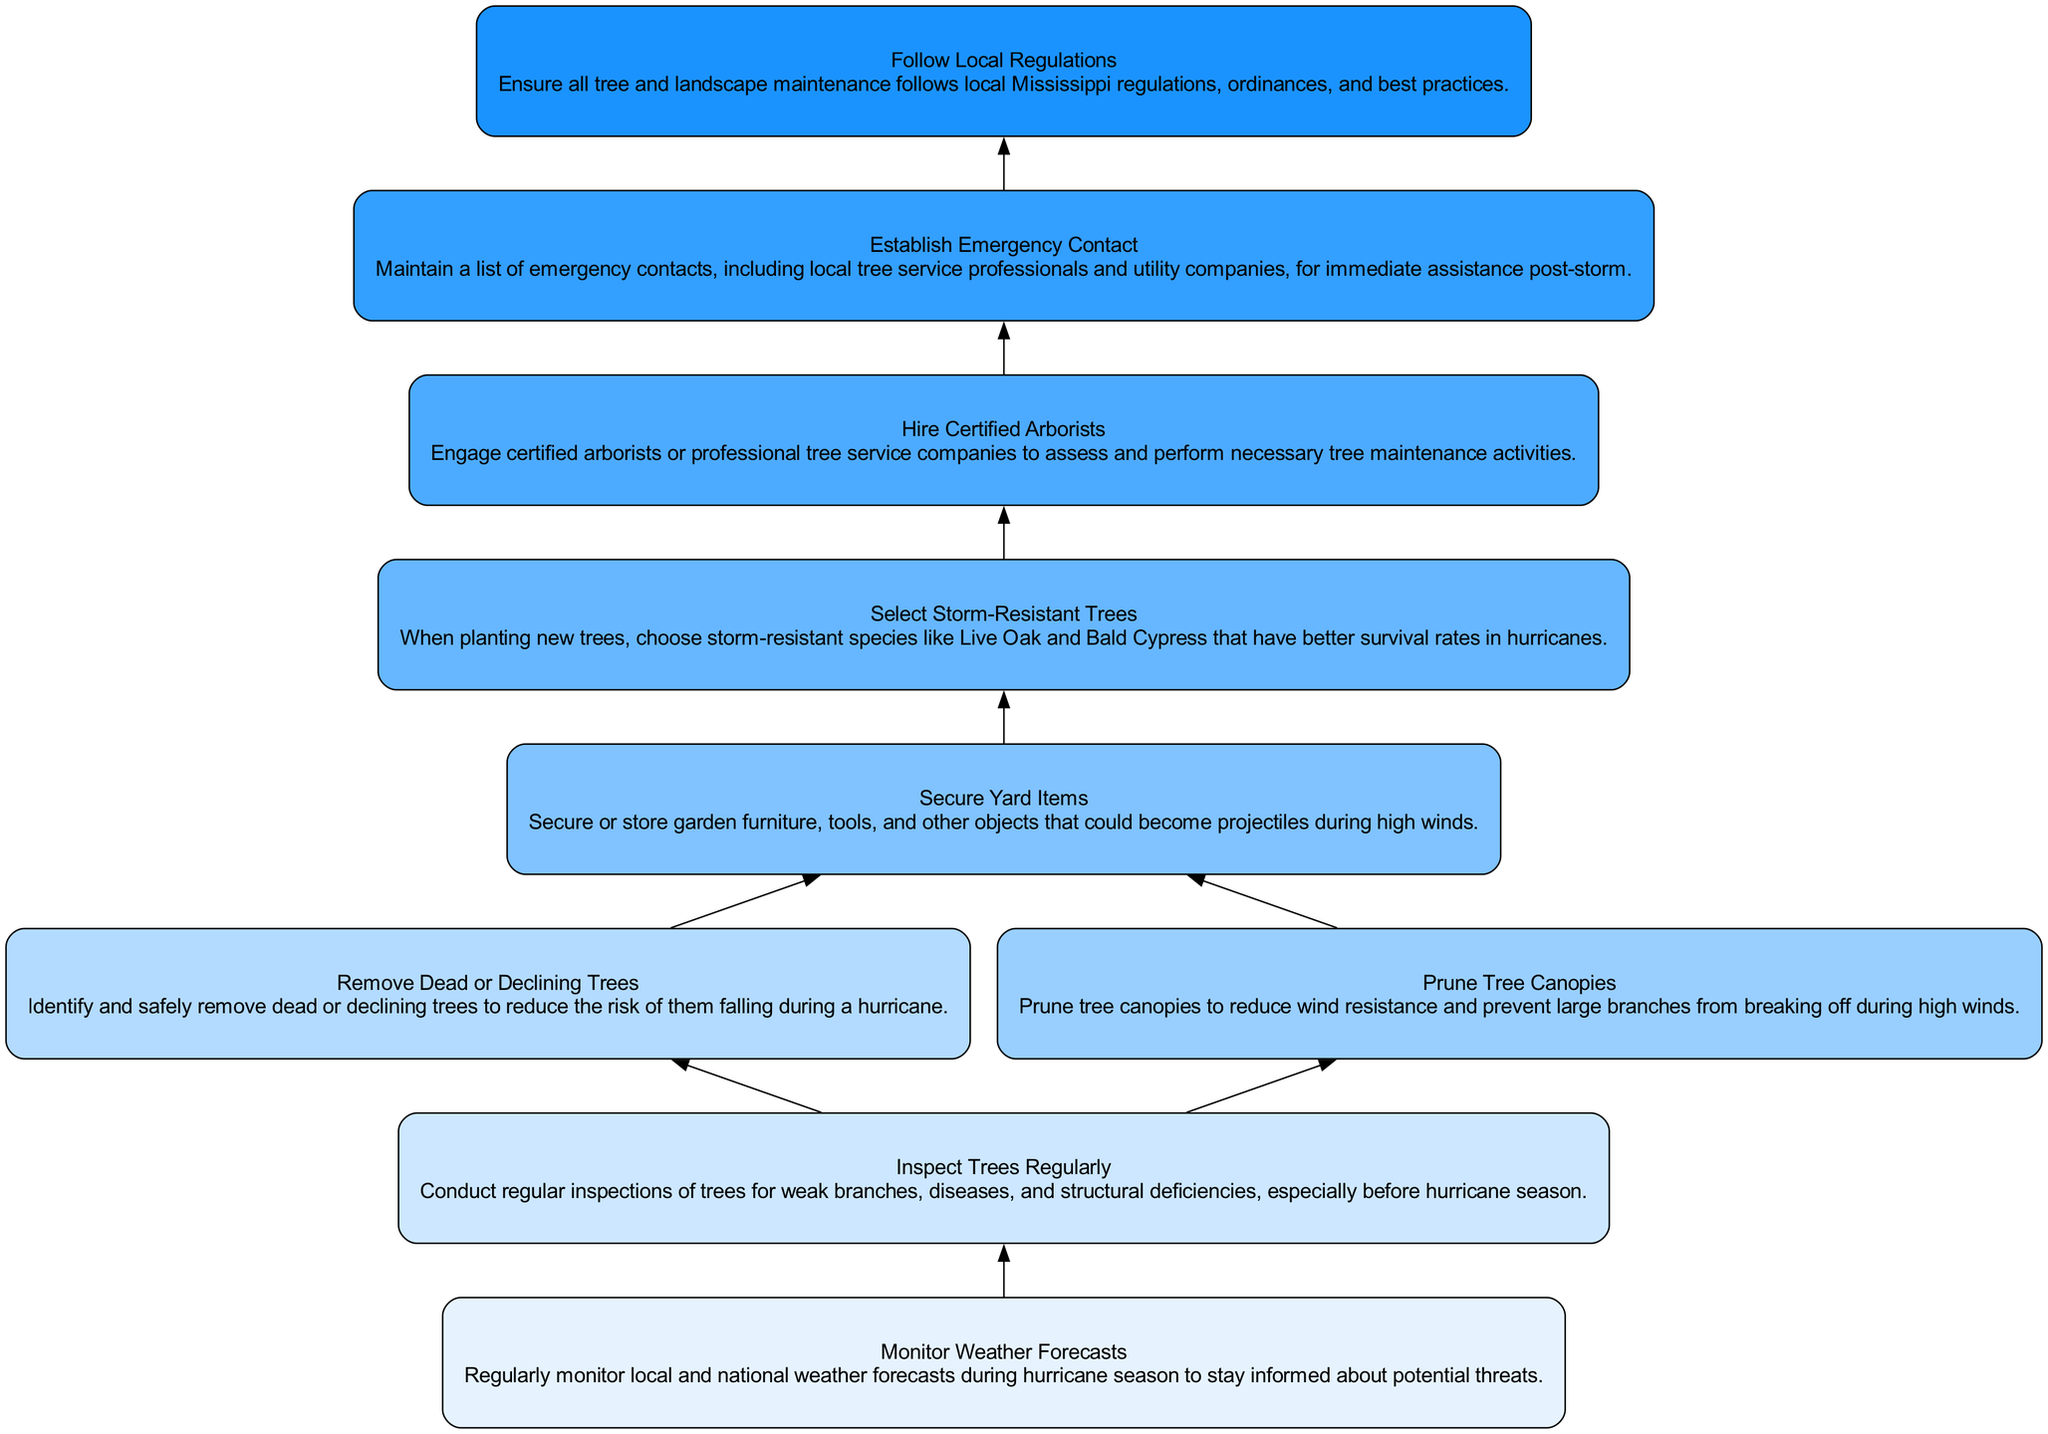What is the first step in the maintenance schedule? The first step in the maintenance schedule is to monitor local and national weather forecasts. This is indicated by the bottom node in the flowchart.
Answer: Monitor Weather Forecasts How many edges are present in the diagram? To find the number of edges, we can count the connections between the nodes. In this flowchart, there are nine edges connecting the steps.
Answer: 9 Which step follows "Inspect Trees Regularly"? Looking at the flow from bottom to top, after "Inspect Trees Regularly," the next step is "Remove Dead or Declining Trees." This is directly connected above it in the diagram.
Answer: Remove Dead or Declining Trees What type of trees should be chosen when planting to prevent hurricane damage? The diagram specifies selecting storm-resistant species like Live Oak and Bald Cypress when planting new trees for prevention against hurricane damage.
Answer: Storm-Resistant Trees What is the ultimate goal of the entire maintenance schedule? The ultimate goal is to ensure all tree and landscape maintenance follows local Mississippi regulations, ordinances, and best practices, as shown at the top of the flowchart.
Answer: Follow Local Regulations What step involves engaging professional help? The step that involves engaging professional help is "Hire Certified Arborists," which comes after selecting storm-resistant trees.
Answer: Hire Certified Arborists What action should be taken after removing dead or declining trees? The next action after removing dead or declining trees is to secure yard items, which is indicated as the following step in the flowchart.
Answer: Secure Yard Items Which node indicates to maintain emergency contacts? The node that indicates maintaining emergency contacts is "Establish Emergency Contact," which is positioned before following local regulations in the diagram.
Answer: Establish Emergency Contact How many main tasks are there in the maintenance process? The main tasks represented in the diagram include monitoring weather, inspecting trees, removing unsafe trees, pruning canopies, securing items, selecting trees, hiring professionals, establishing contact, and following regulations, totaling nine tasks.
Answer: 9 